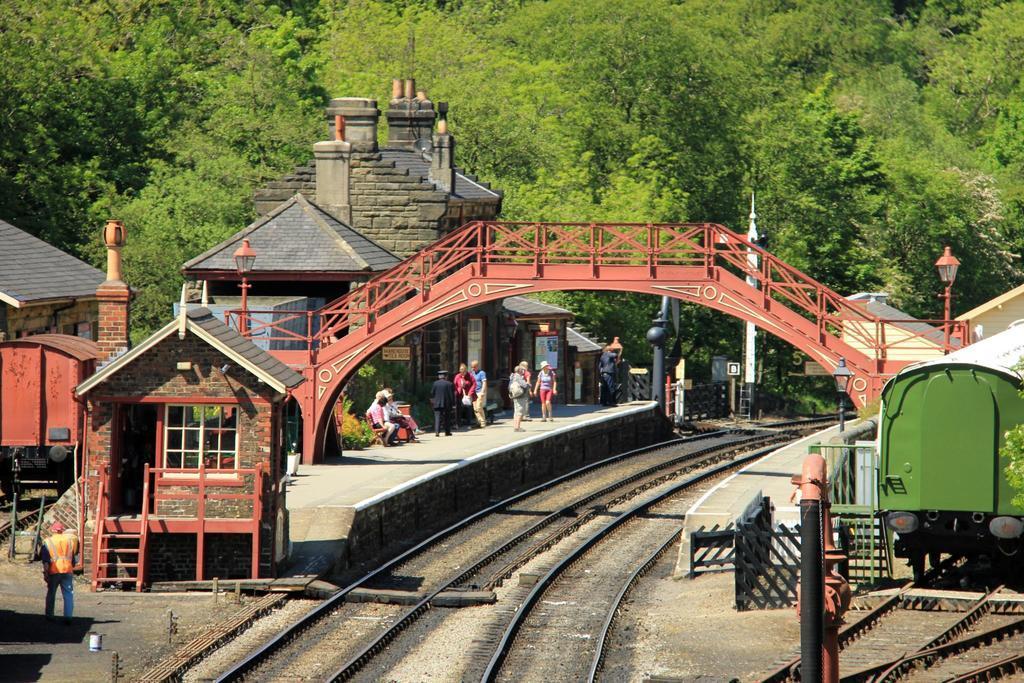In one or two sentences, can you explain what this image depicts? In this picture we can observe a railway station. There are two railway tracks and a bridge over the tracks. We can observe some people standing on the platform. In the background there are trees. 